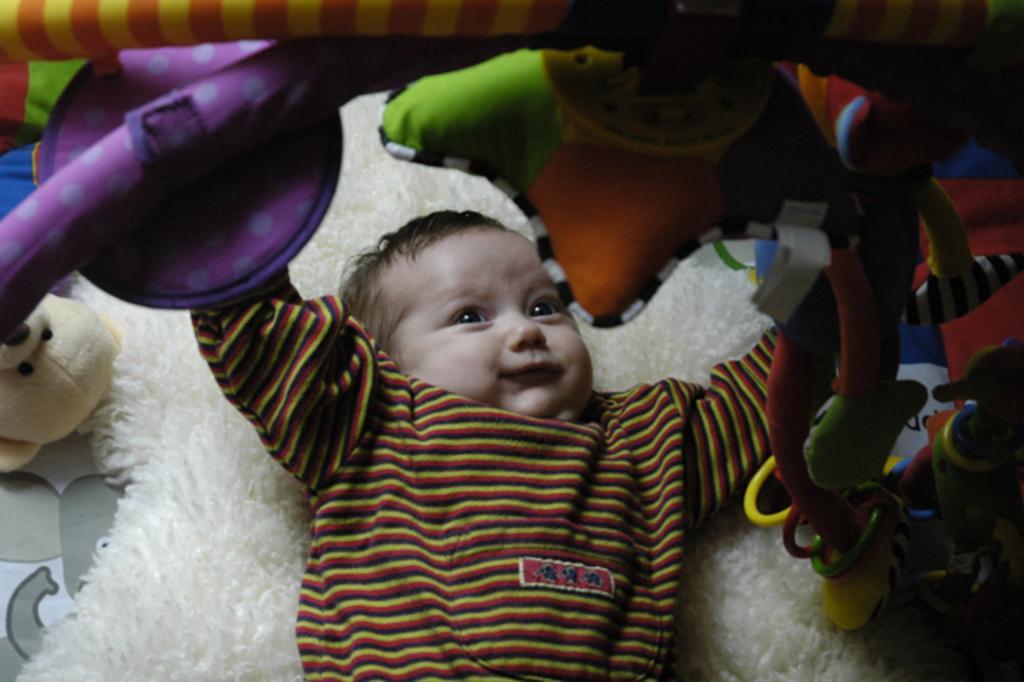In one or two sentences, can you explain what this image depicts? In this image, I can see a baby lying on a bed. At the top of the image, I can see the toys to a rod. On the left side of the image, I can see a teddy bear. 